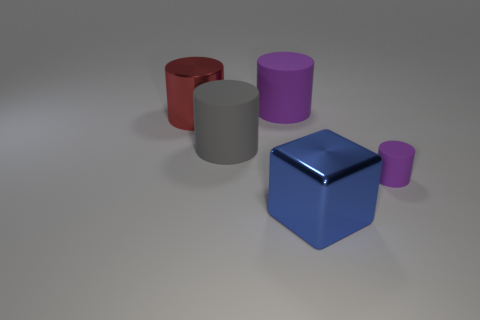Subtract all metal cylinders. How many cylinders are left? 3 Add 1 purple matte things. How many objects exist? 6 Subtract all red cylinders. How many cylinders are left? 3 Subtract 4 cylinders. How many cylinders are left? 0 Subtract all cylinders. How many objects are left? 1 Subtract all cyan blocks. Subtract all red cylinders. How many blocks are left? 1 Subtract all cyan cylinders. How many green blocks are left? 0 Subtract all large blue cubes. Subtract all small things. How many objects are left? 3 Add 5 large gray objects. How many large gray objects are left? 6 Add 4 small purple matte cylinders. How many small purple matte cylinders exist? 5 